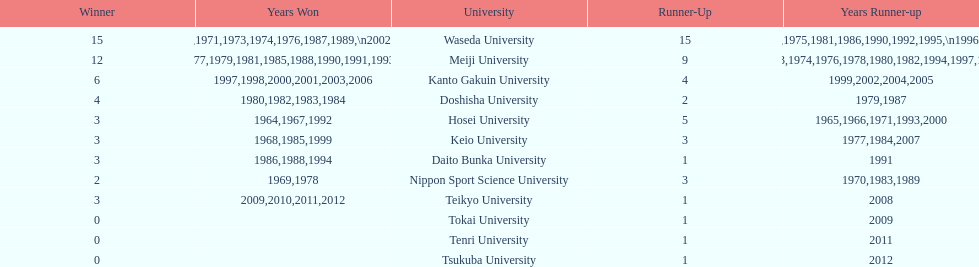How many championships does nippon sport science university have 2. 